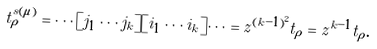<formula> <loc_0><loc_0><loc_500><loc_500>t _ { \rho } ^ { s ( \mu ) } = \cdots [ j _ { 1 } \cdots j _ { k } ] [ i _ { 1 } \cdots i _ { k } ] \cdots = z ^ { ( k - 1 ) ^ { 2 } } t _ { \rho } = z ^ { k - 1 } t _ { \rho } .</formula> 